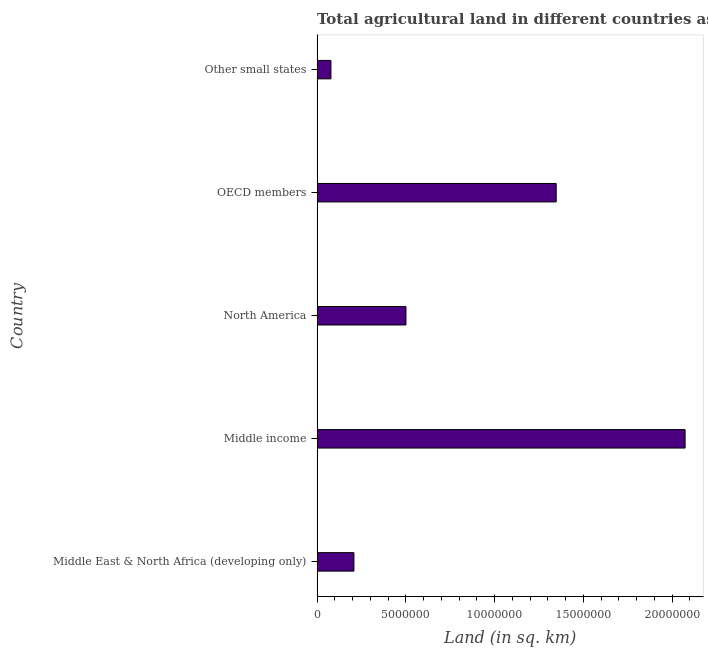Does the graph contain grids?
Offer a terse response. No. What is the title of the graph?
Your answer should be very brief. Total agricultural land in different countries as per the survey report of the year 1972. What is the label or title of the X-axis?
Your answer should be compact. Land (in sq. km). What is the label or title of the Y-axis?
Make the answer very short. Country. What is the agricultural land in Other small states?
Offer a very short reply. 7.82e+05. Across all countries, what is the maximum agricultural land?
Your answer should be very brief. 2.07e+07. Across all countries, what is the minimum agricultural land?
Your response must be concise. 7.82e+05. In which country was the agricultural land minimum?
Your answer should be very brief. Other small states. What is the sum of the agricultural land?
Provide a succinct answer. 4.21e+07. What is the difference between the agricultural land in Middle East & North Africa (developing only) and North America?
Your answer should be very brief. -2.93e+06. What is the average agricultural land per country?
Provide a short and direct response. 8.42e+06. What is the median agricultural land?
Your response must be concise. 5.01e+06. What is the ratio of the agricultural land in North America to that in OECD members?
Keep it short and to the point. 0.37. Is the difference between the agricultural land in North America and OECD members greater than the difference between any two countries?
Your answer should be very brief. No. What is the difference between the highest and the second highest agricultural land?
Your answer should be compact. 7.26e+06. Is the sum of the agricultural land in North America and OECD members greater than the maximum agricultural land across all countries?
Your response must be concise. No. What is the difference between the highest and the lowest agricultural land?
Offer a terse response. 2.00e+07. In how many countries, is the agricultural land greater than the average agricultural land taken over all countries?
Your answer should be very brief. 2. Are all the bars in the graph horizontal?
Offer a very short reply. Yes. How many countries are there in the graph?
Your answer should be very brief. 5. What is the Land (in sq. km) in Middle East & North Africa (developing only)?
Provide a short and direct response. 2.08e+06. What is the Land (in sq. km) of Middle income?
Your answer should be compact. 2.07e+07. What is the Land (in sq. km) of North America?
Your response must be concise. 5.01e+06. What is the Land (in sq. km) in OECD members?
Keep it short and to the point. 1.35e+07. What is the Land (in sq. km) of Other small states?
Offer a terse response. 7.82e+05. What is the difference between the Land (in sq. km) in Middle East & North Africa (developing only) and Middle income?
Keep it short and to the point. -1.87e+07. What is the difference between the Land (in sq. km) in Middle East & North Africa (developing only) and North America?
Keep it short and to the point. -2.93e+06. What is the difference between the Land (in sq. km) in Middle East & North Africa (developing only) and OECD members?
Provide a short and direct response. -1.14e+07. What is the difference between the Land (in sq. km) in Middle East & North Africa (developing only) and Other small states?
Keep it short and to the point. 1.30e+06. What is the difference between the Land (in sq. km) in Middle income and North America?
Provide a short and direct response. 1.57e+07. What is the difference between the Land (in sq. km) in Middle income and OECD members?
Give a very brief answer. 7.26e+06. What is the difference between the Land (in sq. km) in Middle income and Other small states?
Your answer should be very brief. 2.00e+07. What is the difference between the Land (in sq. km) in North America and OECD members?
Offer a terse response. -8.47e+06. What is the difference between the Land (in sq. km) in North America and Other small states?
Keep it short and to the point. 4.23e+06. What is the difference between the Land (in sq. km) in OECD members and Other small states?
Your answer should be very brief. 1.27e+07. What is the ratio of the Land (in sq. km) in Middle East & North Africa (developing only) to that in Middle income?
Give a very brief answer. 0.1. What is the ratio of the Land (in sq. km) in Middle East & North Africa (developing only) to that in North America?
Make the answer very short. 0.41. What is the ratio of the Land (in sq. km) in Middle East & North Africa (developing only) to that in OECD members?
Make the answer very short. 0.15. What is the ratio of the Land (in sq. km) in Middle East & North Africa (developing only) to that in Other small states?
Make the answer very short. 2.66. What is the ratio of the Land (in sq. km) in Middle income to that in North America?
Ensure brevity in your answer.  4.14. What is the ratio of the Land (in sq. km) in Middle income to that in OECD members?
Your answer should be compact. 1.54. What is the ratio of the Land (in sq. km) in Middle income to that in Other small states?
Give a very brief answer. 26.52. What is the ratio of the Land (in sq. km) in North America to that in OECD members?
Your response must be concise. 0.37. What is the ratio of the Land (in sq. km) in North America to that in Other small states?
Keep it short and to the point. 6.41. What is the ratio of the Land (in sq. km) in OECD members to that in Other small states?
Keep it short and to the point. 17.23. 